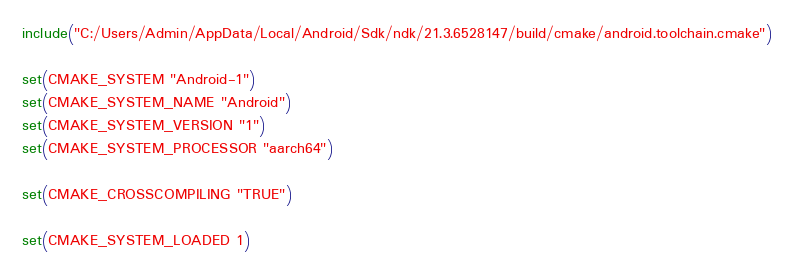Convert code to text. <code><loc_0><loc_0><loc_500><loc_500><_CMake_>include("C:/Users/Admin/AppData/Local/Android/Sdk/ndk/21.3.6528147/build/cmake/android.toolchain.cmake")

set(CMAKE_SYSTEM "Android-1")
set(CMAKE_SYSTEM_NAME "Android")
set(CMAKE_SYSTEM_VERSION "1")
set(CMAKE_SYSTEM_PROCESSOR "aarch64")

set(CMAKE_CROSSCOMPILING "TRUE")

set(CMAKE_SYSTEM_LOADED 1)
</code> 